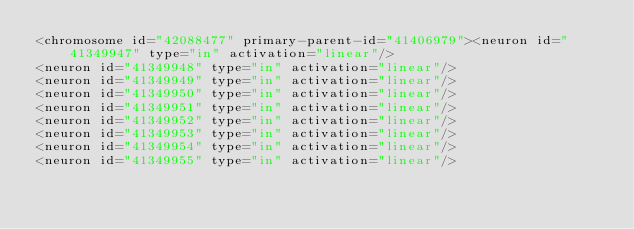Convert code to text. <code><loc_0><loc_0><loc_500><loc_500><_XML_><chromosome id="42088477" primary-parent-id="41406979"><neuron id="41349947" type="in" activation="linear"/>
<neuron id="41349948" type="in" activation="linear"/>
<neuron id="41349949" type="in" activation="linear"/>
<neuron id="41349950" type="in" activation="linear"/>
<neuron id="41349951" type="in" activation="linear"/>
<neuron id="41349952" type="in" activation="linear"/>
<neuron id="41349953" type="in" activation="linear"/>
<neuron id="41349954" type="in" activation="linear"/>
<neuron id="41349955" type="in" activation="linear"/></code> 